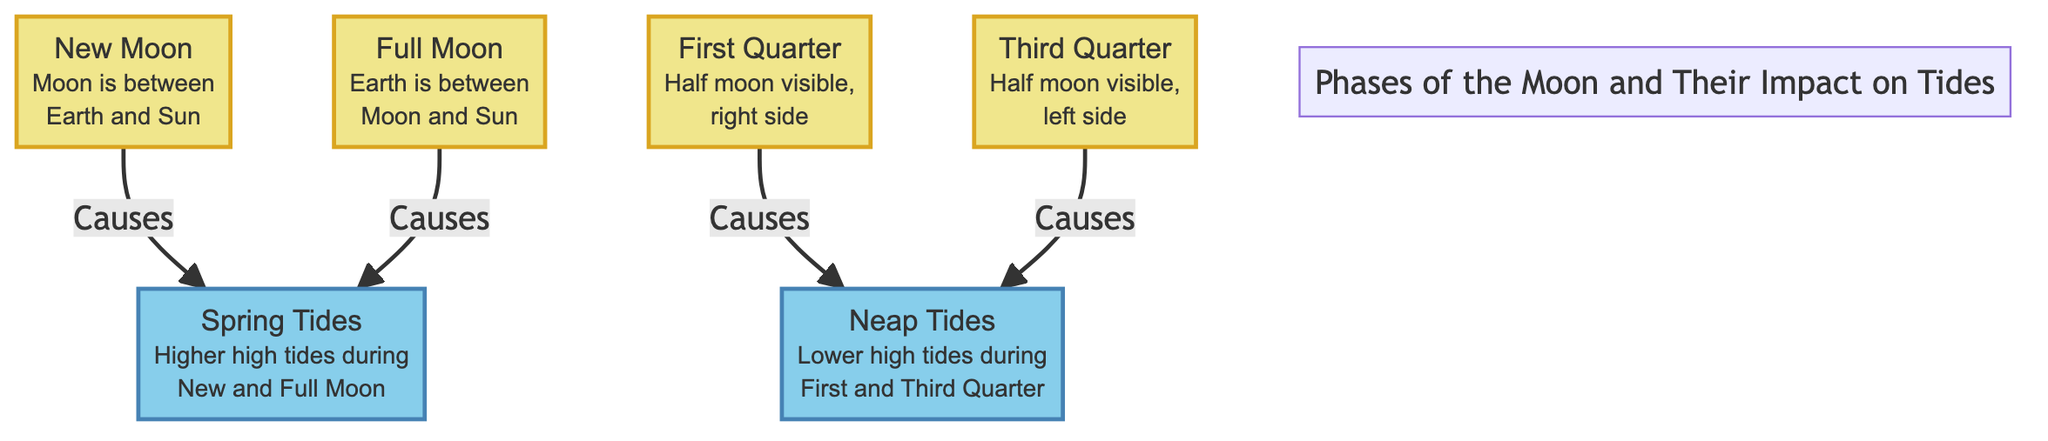What are the two main phases that cause spring tides? The diagram indicates that spring tides are caused by the New Moon and Full Moon phases. These are connected directly through arrows labeled "Causes" leading from both phases to the Spring Tides node.
Answer: New Moon, Full Moon How many types of tides are depicted in the diagram? The diagram shows two types of tides: Spring Tides and Neap Tides. Each type is represented in distinct nodes linked to their respective moon phases. Hence, the count is straightforward by observing these nodes.
Answer: 2 Which moon phase results in neap tides? According to the diagram, both the First Quarter and Third Quarter phases lead to neap tides as they are directly connected by arrows labeled "Causes" to the Neap Tides node.
Answer: First Quarter, Third Quarter What is the relationship between the New Moon and Spring Tides? The diagram illustrates a direct cause-effect relationship where the New Moon phase points to Spring Tides, indicating that the New Moon causes Spring Tides.
Answer: Causes During which phase of the moon is the Earth positioned between the Moon and the Sun? The diagram specifies that during the Full Moon phase, the Earth is located between the Moon and the Sun, as indicated in the description of the Full Moon node.
Answer: Full Moon What do spring tides entail? The diagram clearly defines Spring Tides, stating they are characterized by higher high tides occurring during the New and Full Moon phases. This is highlighted in the Spring Tides node.
Answer: Higher high tides What lunar phase is associated with a half moon visible on the right side? Per the diagram, the First Quarter phase is described as having a half moon visible on the right side, with this specific detail being part of the node's description.
Answer: First Quarter What natural phenomenon exhibits lower high tides during the First and Third Quarter? The diagram notes that Neap Tides are the phenomenon characterized by lower high tides occurring during the First and Third Quarter phases of the moon. This relationship is shown in the arrow connection from the moon phases to the Neap Tides node.
Answer: Neap Tides 